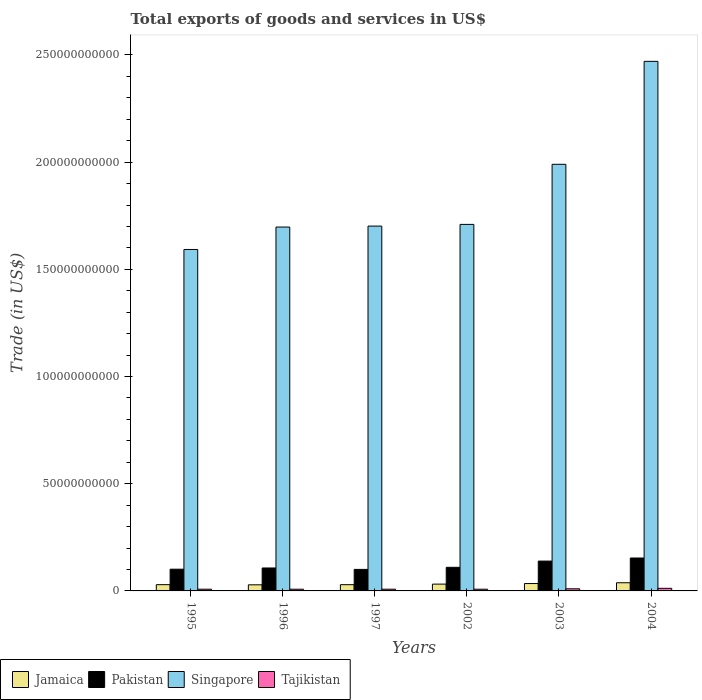How many different coloured bars are there?
Make the answer very short. 4. Are the number of bars on each tick of the X-axis equal?
Give a very brief answer. Yes. What is the total exports of goods and services in Jamaica in 2003?
Make the answer very short. 3.44e+09. Across all years, what is the maximum total exports of goods and services in Pakistan?
Your answer should be very brief. 1.54e+1. Across all years, what is the minimum total exports of goods and services in Tajikistan?
Your response must be concise. 7.99e+08. In which year was the total exports of goods and services in Singapore minimum?
Your response must be concise. 1995. What is the total total exports of goods and services in Tajikistan in the graph?
Ensure brevity in your answer.  5.41e+09. What is the difference between the total exports of goods and services in Jamaica in 1997 and that in 2004?
Ensure brevity in your answer.  -8.97e+08. What is the difference between the total exports of goods and services in Tajikistan in 2003 and the total exports of goods and services in Jamaica in 2004?
Give a very brief answer. -2.83e+09. What is the average total exports of goods and services in Singapore per year?
Your answer should be very brief. 1.86e+11. In the year 1996, what is the difference between the total exports of goods and services in Jamaica and total exports of goods and services in Singapore?
Make the answer very short. -1.67e+11. What is the ratio of the total exports of goods and services in Tajikistan in 2003 to that in 2004?
Give a very brief answer. 0.81. What is the difference between the highest and the second highest total exports of goods and services in Pakistan?
Keep it short and to the point. 1.43e+09. What is the difference between the highest and the lowest total exports of goods and services in Jamaica?
Make the answer very short. 9.63e+08. In how many years, is the total exports of goods and services in Singapore greater than the average total exports of goods and services in Singapore taken over all years?
Provide a succinct answer. 2. Is the sum of the total exports of goods and services in Jamaica in 1995 and 2004 greater than the maximum total exports of goods and services in Tajikistan across all years?
Ensure brevity in your answer.  Yes. Is it the case that in every year, the sum of the total exports of goods and services in Singapore and total exports of goods and services in Jamaica is greater than the sum of total exports of goods and services in Pakistan and total exports of goods and services in Tajikistan?
Ensure brevity in your answer.  No. What does the 1st bar from the left in 2004 represents?
Provide a short and direct response. Jamaica. What does the 4th bar from the right in 2003 represents?
Offer a terse response. Jamaica. Are all the bars in the graph horizontal?
Keep it short and to the point. No. Where does the legend appear in the graph?
Offer a terse response. Bottom left. What is the title of the graph?
Offer a terse response. Total exports of goods and services in US$. What is the label or title of the Y-axis?
Ensure brevity in your answer.  Trade (in US$). What is the Trade (in US$) in Jamaica in 1995?
Offer a very short reply. 2.92e+09. What is the Trade (in US$) in Pakistan in 1995?
Offer a terse response. 1.01e+1. What is the Trade (in US$) of Singapore in 1995?
Your answer should be very brief. 1.59e+11. What is the Trade (in US$) in Tajikistan in 1995?
Offer a very short reply. 8.08e+08. What is the Trade (in US$) of Jamaica in 1996?
Offer a very short reply. 2.85e+09. What is the Trade (in US$) in Pakistan in 1996?
Your answer should be compact. 1.07e+1. What is the Trade (in US$) in Singapore in 1996?
Keep it short and to the point. 1.70e+11. What is the Trade (in US$) of Tajikistan in 1996?
Make the answer very short. 8.00e+08. What is the Trade (in US$) of Jamaica in 1997?
Make the answer very short. 2.91e+09. What is the Trade (in US$) of Pakistan in 1997?
Offer a very short reply. 1.00e+1. What is the Trade (in US$) in Singapore in 1997?
Your response must be concise. 1.70e+11. What is the Trade (in US$) of Tajikistan in 1997?
Provide a short and direct response. 8.04e+08. What is the Trade (in US$) in Jamaica in 2002?
Offer a terse response. 3.18e+09. What is the Trade (in US$) in Pakistan in 2002?
Provide a succinct answer. 1.10e+1. What is the Trade (in US$) of Singapore in 2002?
Give a very brief answer. 1.71e+11. What is the Trade (in US$) of Tajikistan in 2002?
Give a very brief answer. 7.99e+08. What is the Trade (in US$) of Jamaica in 2003?
Provide a succinct answer. 3.44e+09. What is the Trade (in US$) in Pakistan in 2003?
Your response must be concise. 1.39e+1. What is the Trade (in US$) of Singapore in 2003?
Make the answer very short. 1.99e+11. What is the Trade (in US$) in Tajikistan in 2003?
Make the answer very short. 9.85e+08. What is the Trade (in US$) of Jamaica in 2004?
Offer a very short reply. 3.81e+09. What is the Trade (in US$) of Pakistan in 2004?
Your answer should be very brief. 1.54e+1. What is the Trade (in US$) in Singapore in 2004?
Provide a short and direct response. 2.47e+11. What is the Trade (in US$) in Tajikistan in 2004?
Ensure brevity in your answer.  1.21e+09. Across all years, what is the maximum Trade (in US$) of Jamaica?
Ensure brevity in your answer.  3.81e+09. Across all years, what is the maximum Trade (in US$) of Pakistan?
Make the answer very short. 1.54e+1. Across all years, what is the maximum Trade (in US$) of Singapore?
Your response must be concise. 2.47e+11. Across all years, what is the maximum Trade (in US$) of Tajikistan?
Offer a very short reply. 1.21e+09. Across all years, what is the minimum Trade (in US$) in Jamaica?
Give a very brief answer. 2.85e+09. Across all years, what is the minimum Trade (in US$) in Pakistan?
Your answer should be very brief. 1.00e+1. Across all years, what is the minimum Trade (in US$) in Singapore?
Your answer should be very brief. 1.59e+11. Across all years, what is the minimum Trade (in US$) in Tajikistan?
Your answer should be compact. 7.99e+08. What is the total Trade (in US$) of Jamaica in the graph?
Keep it short and to the point. 1.91e+1. What is the total Trade (in US$) of Pakistan in the graph?
Your response must be concise. 7.12e+1. What is the total Trade (in US$) in Singapore in the graph?
Offer a very short reply. 1.12e+12. What is the total Trade (in US$) in Tajikistan in the graph?
Give a very brief answer. 5.41e+09. What is the difference between the Trade (in US$) of Jamaica in 1995 and that in 1996?
Your answer should be very brief. 7.17e+07. What is the difference between the Trade (in US$) of Pakistan in 1995 and that in 1996?
Give a very brief answer. -5.71e+08. What is the difference between the Trade (in US$) of Singapore in 1995 and that in 1996?
Offer a terse response. -1.05e+1. What is the difference between the Trade (in US$) in Tajikistan in 1995 and that in 1996?
Provide a succinct answer. 8.20e+06. What is the difference between the Trade (in US$) of Jamaica in 1995 and that in 1997?
Make the answer very short. 6.07e+06. What is the difference between the Trade (in US$) in Pakistan in 1995 and that in 1997?
Your answer should be very brief. 9.18e+07. What is the difference between the Trade (in US$) of Singapore in 1995 and that in 1997?
Keep it short and to the point. -1.09e+1. What is the difference between the Trade (in US$) of Tajikistan in 1995 and that in 1997?
Make the answer very short. 3.50e+06. What is the difference between the Trade (in US$) of Jamaica in 1995 and that in 2002?
Offer a terse response. -2.56e+08. What is the difference between the Trade (in US$) of Pakistan in 1995 and that in 2002?
Ensure brevity in your answer.  -8.75e+08. What is the difference between the Trade (in US$) of Singapore in 1995 and that in 2002?
Make the answer very short. -1.17e+1. What is the difference between the Trade (in US$) in Tajikistan in 1995 and that in 2002?
Offer a very short reply. 8.34e+06. What is the difference between the Trade (in US$) in Jamaica in 1995 and that in 2003?
Your response must be concise. -5.22e+08. What is the difference between the Trade (in US$) of Pakistan in 1995 and that in 2003?
Your answer should be very brief. -3.79e+09. What is the difference between the Trade (in US$) in Singapore in 1995 and that in 2003?
Give a very brief answer. -3.97e+1. What is the difference between the Trade (in US$) of Tajikistan in 1995 and that in 2003?
Offer a terse response. -1.77e+08. What is the difference between the Trade (in US$) in Jamaica in 1995 and that in 2004?
Keep it short and to the point. -8.91e+08. What is the difference between the Trade (in US$) of Pakistan in 1995 and that in 2004?
Your answer should be very brief. -5.22e+09. What is the difference between the Trade (in US$) of Singapore in 1995 and that in 2004?
Your answer should be very brief. -8.78e+1. What is the difference between the Trade (in US$) of Tajikistan in 1995 and that in 2004?
Ensure brevity in your answer.  -4.03e+08. What is the difference between the Trade (in US$) of Jamaica in 1996 and that in 1997?
Offer a very short reply. -6.57e+07. What is the difference between the Trade (in US$) in Pakistan in 1996 and that in 1997?
Offer a terse response. 6.63e+08. What is the difference between the Trade (in US$) in Singapore in 1996 and that in 1997?
Offer a very short reply. -4.45e+08. What is the difference between the Trade (in US$) of Tajikistan in 1996 and that in 1997?
Ensure brevity in your answer.  -4.70e+06. What is the difference between the Trade (in US$) in Jamaica in 1996 and that in 2002?
Offer a very short reply. -3.28e+08. What is the difference between the Trade (in US$) of Pakistan in 1996 and that in 2002?
Your answer should be very brief. -3.05e+08. What is the difference between the Trade (in US$) of Singapore in 1996 and that in 2002?
Keep it short and to the point. -1.24e+09. What is the difference between the Trade (in US$) in Tajikistan in 1996 and that in 2002?
Your answer should be very brief. 1.45e+05. What is the difference between the Trade (in US$) of Jamaica in 1996 and that in 2003?
Keep it short and to the point. -5.93e+08. What is the difference between the Trade (in US$) of Pakistan in 1996 and that in 2003?
Ensure brevity in your answer.  -3.21e+09. What is the difference between the Trade (in US$) of Singapore in 1996 and that in 2003?
Your answer should be compact. -2.93e+1. What is the difference between the Trade (in US$) in Tajikistan in 1996 and that in 2003?
Provide a succinct answer. -1.85e+08. What is the difference between the Trade (in US$) in Jamaica in 1996 and that in 2004?
Give a very brief answer. -9.63e+08. What is the difference between the Trade (in US$) of Pakistan in 1996 and that in 2004?
Offer a very short reply. -4.65e+09. What is the difference between the Trade (in US$) of Singapore in 1996 and that in 2004?
Offer a terse response. -7.73e+1. What is the difference between the Trade (in US$) of Tajikistan in 1996 and that in 2004?
Make the answer very short. -4.11e+08. What is the difference between the Trade (in US$) of Jamaica in 1997 and that in 2002?
Your answer should be compact. -2.62e+08. What is the difference between the Trade (in US$) in Pakistan in 1997 and that in 2002?
Your answer should be compact. -9.67e+08. What is the difference between the Trade (in US$) of Singapore in 1997 and that in 2002?
Offer a very short reply. -7.93e+08. What is the difference between the Trade (in US$) of Tajikistan in 1997 and that in 2002?
Offer a very short reply. 4.84e+06. What is the difference between the Trade (in US$) of Jamaica in 1997 and that in 2003?
Offer a terse response. -5.28e+08. What is the difference between the Trade (in US$) of Pakistan in 1997 and that in 2003?
Provide a succinct answer. -3.88e+09. What is the difference between the Trade (in US$) of Singapore in 1997 and that in 2003?
Your answer should be compact. -2.88e+1. What is the difference between the Trade (in US$) of Tajikistan in 1997 and that in 2003?
Your answer should be very brief. -1.81e+08. What is the difference between the Trade (in US$) in Jamaica in 1997 and that in 2004?
Your answer should be very brief. -8.97e+08. What is the difference between the Trade (in US$) of Pakistan in 1997 and that in 2004?
Ensure brevity in your answer.  -5.31e+09. What is the difference between the Trade (in US$) of Singapore in 1997 and that in 2004?
Offer a very short reply. -7.68e+1. What is the difference between the Trade (in US$) in Tajikistan in 1997 and that in 2004?
Provide a succinct answer. -4.06e+08. What is the difference between the Trade (in US$) in Jamaica in 2002 and that in 2003?
Keep it short and to the point. -2.65e+08. What is the difference between the Trade (in US$) of Pakistan in 2002 and that in 2003?
Offer a very short reply. -2.91e+09. What is the difference between the Trade (in US$) in Singapore in 2002 and that in 2003?
Ensure brevity in your answer.  -2.80e+1. What is the difference between the Trade (in US$) of Tajikistan in 2002 and that in 2003?
Your answer should be compact. -1.86e+08. What is the difference between the Trade (in US$) in Jamaica in 2002 and that in 2004?
Your response must be concise. -6.35e+08. What is the difference between the Trade (in US$) in Pakistan in 2002 and that in 2004?
Your response must be concise. -4.34e+09. What is the difference between the Trade (in US$) in Singapore in 2002 and that in 2004?
Make the answer very short. -7.61e+1. What is the difference between the Trade (in US$) in Tajikistan in 2002 and that in 2004?
Your response must be concise. -4.11e+08. What is the difference between the Trade (in US$) of Jamaica in 2003 and that in 2004?
Make the answer very short. -3.70e+08. What is the difference between the Trade (in US$) of Pakistan in 2003 and that in 2004?
Provide a succinct answer. -1.43e+09. What is the difference between the Trade (in US$) in Singapore in 2003 and that in 2004?
Keep it short and to the point. -4.80e+1. What is the difference between the Trade (in US$) of Tajikistan in 2003 and that in 2004?
Ensure brevity in your answer.  -2.26e+08. What is the difference between the Trade (in US$) in Jamaica in 1995 and the Trade (in US$) in Pakistan in 1996?
Keep it short and to the point. -7.78e+09. What is the difference between the Trade (in US$) in Jamaica in 1995 and the Trade (in US$) in Singapore in 1996?
Give a very brief answer. -1.67e+11. What is the difference between the Trade (in US$) of Jamaica in 1995 and the Trade (in US$) of Tajikistan in 1996?
Your answer should be very brief. 2.12e+09. What is the difference between the Trade (in US$) in Pakistan in 1995 and the Trade (in US$) in Singapore in 1996?
Make the answer very short. -1.60e+11. What is the difference between the Trade (in US$) in Pakistan in 1995 and the Trade (in US$) in Tajikistan in 1996?
Offer a terse response. 9.33e+09. What is the difference between the Trade (in US$) in Singapore in 1995 and the Trade (in US$) in Tajikistan in 1996?
Your answer should be compact. 1.58e+11. What is the difference between the Trade (in US$) of Jamaica in 1995 and the Trade (in US$) of Pakistan in 1997?
Your answer should be compact. -7.12e+09. What is the difference between the Trade (in US$) of Jamaica in 1995 and the Trade (in US$) of Singapore in 1997?
Ensure brevity in your answer.  -1.67e+11. What is the difference between the Trade (in US$) of Jamaica in 1995 and the Trade (in US$) of Tajikistan in 1997?
Provide a succinct answer. 2.12e+09. What is the difference between the Trade (in US$) in Pakistan in 1995 and the Trade (in US$) in Singapore in 1997?
Your answer should be very brief. -1.60e+11. What is the difference between the Trade (in US$) of Pakistan in 1995 and the Trade (in US$) of Tajikistan in 1997?
Your answer should be very brief. 9.33e+09. What is the difference between the Trade (in US$) of Singapore in 1995 and the Trade (in US$) of Tajikistan in 1997?
Offer a terse response. 1.58e+11. What is the difference between the Trade (in US$) in Jamaica in 1995 and the Trade (in US$) in Pakistan in 2002?
Give a very brief answer. -8.09e+09. What is the difference between the Trade (in US$) in Jamaica in 1995 and the Trade (in US$) in Singapore in 2002?
Ensure brevity in your answer.  -1.68e+11. What is the difference between the Trade (in US$) of Jamaica in 1995 and the Trade (in US$) of Tajikistan in 2002?
Ensure brevity in your answer.  2.12e+09. What is the difference between the Trade (in US$) in Pakistan in 1995 and the Trade (in US$) in Singapore in 2002?
Offer a terse response. -1.61e+11. What is the difference between the Trade (in US$) of Pakistan in 1995 and the Trade (in US$) of Tajikistan in 2002?
Give a very brief answer. 9.33e+09. What is the difference between the Trade (in US$) in Singapore in 1995 and the Trade (in US$) in Tajikistan in 2002?
Ensure brevity in your answer.  1.58e+11. What is the difference between the Trade (in US$) in Jamaica in 1995 and the Trade (in US$) in Pakistan in 2003?
Give a very brief answer. -1.10e+1. What is the difference between the Trade (in US$) of Jamaica in 1995 and the Trade (in US$) of Singapore in 2003?
Provide a succinct answer. -1.96e+11. What is the difference between the Trade (in US$) of Jamaica in 1995 and the Trade (in US$) of Tajikistan in 2003?
Provide a short and direct response. 1.93e+09. What is the difference between the Trade (in US$) in Pakistan in 1995 and the Trade (in US$) in Singapore in 2003?
Ensure brevity in your answer.  -1.89e+11. What is the difference between the Trade (in US$) of Pakistan in 1995 and the Trade (in US$) of Tajikistan in 2003?
Keep it short and to the point. 9.15e+09. What is the difference between the Trade (in US$) of Singapore in 1995 and the Trade (in US$) of Tajikistan in 2003?
Give a very brief answer. 1.58e+11. What is the difference between the Trade (in US$) of Jamaica in 1995 and the Trade (in US$) of Pakistan in 2004?
Your answer should be compact. -1.24e+1. What is the difference between the Trade (in US$) in Jamaica in 1995 and the Trade (in US$) in Singapore in 2004?
Ensure brevity in your answer.  -2.44e+11. What is the difference between the Trade (in US$) of Jamaica in 1995 and the Trade (in US$) of Tajikistan in 2004?
Keep it short and to the point. 1.71e+09. What is the difference between the Trade (in US$) in Pakistan in 1995 and the Trade (in US$) in Singapore in 2004?
Keep it short and to the point. -2.37e+11. What is the difference between the Trade (in US$) in Pakistan in 1995 and the Trade (in US$) in Tajikistan in 2004?
Make the answer very short. 8.92e+09. What is the difference between the Trade (in US$) of Singapore in 1995 and the Trade (in US$) of Tajikistan in 2004?
Keep it short and to the point. 1.58e+11. What is the difference between the Trade (in US$) of Jamaica in 1996 and the Trade (in US$) of Pakistan in 1997?
Ensure brevity in your answer.  -7.19e+09. What is the difference between the Trade (in US$) of Jamaica in 1996 and the Trade (in US$) of Singapore in 1997?
Give a very brief answer. -1.67e+11. What is the difference between the Trade (in US$) of Jamaica in 1996 and the Trade (in US$) of Tajikistan in 1997?
Offer a terse response. 2.04e+09. What is the difference between the Trade (in US$) in Pakistan in 1996 and the Trade (in US$) in Singapore in 1997?
Ensure brevity in your answer.  -1.59e+11. What is the difference between the Trade (in US$) of Pakistan in 1996 and the Trade (in US$) of Tajikistan in 1997?
Offer a terse response. 9.90e+09. What is the difference between the Trade (in US$) in Singapore in 1996 and the Trade (in US$) in Tajikistan in 1997?
Your response must be concise. 1.69e+11. What is the difference between the Trade (in US$) in Jamaica in 1996 and the Trade (in US$) in Pakistan in 2002?
Offer a very short reply. -8.16e+09. What is the difference between the Trade (in US$) in Jamaica in 1996 and the Trade (in US$) in Singapore in 2002?
Your response must be concise. -1.68e+11. What is the difference between the Trade (in US$) in Jamaica in 1996 and the Trade (in US$) in Tajikistan in 2002?
Give a very brief answer. 2.05e+09. What is the difference between the Trade (in US$) in Pakistan in 1996 and the Trade (in US$) in Singapore in 2002?
Your answer should be compact. -1.60e+11. What is the difference between the Trade (in US$) in Pakistan in 1996 and the Trade (in US$) in Tajikistan in 2002?
Your response must be concise. 9.90e+09. What is the difference between the Trade (in US$) in Singapore in 1996 and the Trade (in US$) in Tajikistan in 2002?
Keep it short and to the point. 1.69e+11. What is the difference between the Trade (in US$) in Jamaica in 1996 and the Trade (in US$) in Pakistan in 2003?
Your response must be concise. -1.11e+1. What is the difference between the Trade (in US$) of Jamaica in 1996 and the Trade (in US$) of Singapore in 2003?
Your response must be concise. -1.96e+11. What is the difference between the Trade (in US$) in Jamaica in 1996 and the Trade (in US$) in Tajikistan in 2003?
Provide a short and direct response. 1.86e+09. What is the difference between the Trade (in US$) in Pakistan in 1996 and the Trade (in US$) in Singapore in 2003?
Ensure brevity in your answer.  -1.88e+11. What is the difference between the Trade (in US$) of Pakistan in 1996 and the Trade (in US$) of Tajikistan in 2003?
Give a very brief answer. 9.72e+09. What is the difference between the Trade (in US$) in Singapore in 1996 and the Trade (in US$) in Tajikistan in 2003?
Provide a short and direct response. 1.69e+11. What is the difference between the Trade (in US$) of Jamaica in 1996 and the Trade (in US$) of Pakistan in 2004?
Make the answer very short. -1.25e+1. What is the difference between the Trade (in US$) in Jamaica in 1996 and the Trade (in US$) in Singapore in 2004?
Your answer should be very brief. -2.44e+11. What is the difference between the Trade (in US$) in Jamaica in 1996 and the Trade (in US$) in Tajikistan in 2004?
Offer a very short reply. 1.64e+09. What is the difference between the Trade (in US$) of Pakistan in 1996 and the Trade (in US$) of Singapore in 2004?
Keep it short and to the point. -2.36e+11. What is the difference between the Trade (in US$) in Pakistan in 1996 and the Trade (in US$) in Tajikistan in 2004?
Offer a very short reply. 9.49e+09. What is the difference between the Trade (in US$) of Singapore in 1996 and the Trade (in US$) of Tajikistan in 2004?
Make the answer very short. 1.69e+11. What is the difference between the Trade (in US$) in Jamaica in 1997 and the Trade (in US$) in Pakistan in 2002?
Provide a succinct answer. -8.09e+09. What is the difference between the Trade (in US$) in Jamaica in 1997 and the Trade (in US$) in Singapore in 2002?
Keep it short and to the point. -1.68e+11. What is the difference between the Trade (in US$) of Jamaica in 1997 and the Trade (in US$) of Tajikistan in 2002?
Make the answer very short. 2.11e+09. What is the difference between the Trade (in US$) of Pakistan in 1997 and the Trade (in US$) of Singapore in 2002?
Ensure brevity in your answer.  -1.61e+11. What is the difference between the Trade (in US$) in Pakistan in 1997 and the Trade (in US$) in Tajikistan in 2002?
Provide a succinct answer. 9.24e+09. What is the difference between the Trade (in US$) in Singapore in 1997 and the Trade (in US$) in Tajikistan in 2002?
Ensure brevity in your answer.  1.69e+11. What is the difference between the Trade (in US$) of Jamaica in 1997 and the Trade (in US$) of Pakistan in 2003?
Your response must be concise. -1.10e+1. What is the difference between the Trade (in US$) of Jamaica in 1997 and the Trade (in US$) of Singapore in 2003?
Your answer should be very brief. -1.96e+11. What is the difference between the Trade (in US$) of Jamaica in 1997 and the Trade (in US$) of Tajikistan in 2003?
Ensure brevity in your answer.  1.93e+09. What is the difference between the Trade (in US$) in Pakistan in 1997 and the Trade (in US$) in Singapore in 2003?
Ensure brevity in your answer.  -1.89e+11. What is the difference between the Trade (in US$) in Pakistan in 1997 and the Trade (in US$) in Tajikistan in 2003?
Keep it short and to the point. 9.06e+09. What is the difference between the Trade (in US$) in Singapore in 1997 and the Trade (in US$) in Tajikistan in 2003?
Your answer should be compact. 1.69e+11. What is the difference between the Trade (in US$) in Jamaica in 1997 and the Trade (in US$) in Pakistan in 2004?
Your answer should be very brief. -1.24e+1. What is the difference between the Trade (in US$) in Jamaica in 1997 and the Trade (in US$) in Singapore in 2004?
Provide a short and direct response. -2.44e+11. What is the difference between the Trade (in US$) in Jamaica in 1997 and the Trade (in US$) in Tajikistan in 2004?
Keep it short and to the point. 1.70e+09. What is the difference between the Trade (in US$) of Pakistan in 1997 and the Trade (in US$) of Singapore in 2004?
Provide a succinct answer. -2.37e+11. What is the difference between the Trade (in US$) of Pakistan in 1997 and the Trade (in US$) of Tajikistan in 2004?
Keep it short and to the point. 8.83e+09. What is the difference between the Trade (in US$) in Singapore in 1997 and the Trade (in US$) in Tajikistan in 2004?
Your answer should be very brief. 1.69e+11. What is the difference between the Trade (in US$) in Jamaica in 2002 and the Trade (in US$) in Pakistan in 2003?
Make the answer very short. -1.07e+1. What is the difference between the Trade (in US$) of Jamaica in 2002 and the Trade (in US$) of Singapore in 2003?
Offer a terse response. -1.96e+11. What is the difference between the Trade (in US$) of Jamaica in 2002 and the Trade (in US$) of Tajikistan in 2003?
Your answer should be very brief. 2.19e+09. What is the difference between the Trade (in US$) in Pakistan in 2002 and the Trade (in US$) in Singapore in 2003?
Offer a terse response. -1.88e+11. What is the difference between the Trade (in US$) of Pakistan in 2002 and the Trade (in US$) of Tajikistan in 2003?
Your answer should be very brief. 1.00e+1. What is the difference between the Trade (in US$) in Singapore in 2002 and the Trade (in US$) in Tajikistan in 2003?
Give a very brief answer. 1.70e+11. What is the difference between the Trade (in US$) of Jamaica in 2002 and the Trade (in US$) of Pakistan in 2004?
Offer a very short reply. -1.22e+1. What is the difference between the Trade (in US$) of Jamaica in 2002 and the Trade (in US$) of Singapore in 2004?
Provide a succinct answer. -2.44e+11. What is the difference between the Trade (in US$) of Jamaica in 2002 and the Trade (in US$) of Tajikistan in 2004?
Ensure brevity in your answer.  1.97e+09. What is the difference between the Trade (in US$) in Pakistan in 2002 and the Trade (in US$) in Singapore in 2004?
Your answer should be compact. -2.36e+11. What is the difference between the Trade (in US$) in Pakistan in 2002 and the Trade (in US$) in Tajikistan in 2004?
Make the answer very short. 9.80e+09. What is the difference between the Trade (in US$) in Singapore in 2002 and the Trade (in US$) in Tajikistan in 2004?
Your answer should be compact. 1.70e+11. What is the difference between the Trade (in US$) in Jamaica in 2003 and the Trade (in US$) in Pakistan in 2004?
Provide a succinct answer. -1.19e+1. What is the difference between the Trade (in US$) of Jamaica in 2003 and the Trade (in US$) of Singapore in 2004?
Provide a succinct answer. -2.44e+11. What is the difference between the Trade (in US$) in Jamaica in 2003 and the Trade (in US$) in Tajikistan in 2004?
Provide a succinct answer. 2.23e+09. What is the difference between the Trade (in US$) in Pakistan in 2003 and the Trade (in US$) in Singapore in 2004?
Keep it short and to the point. -2.33e+11. What is the difference between the Trade (in US$) of Pakistan in 2003 and the Trade (in US$) of Tajikistan in 2004?
Your answer should be compact. 1.27e+1. What is the difference between the Trade (in US$) in Singapore in 2003 and the Trade (in US$) in Tajikistan in 2004?
Provide a succinct answer. 1.98e+11. What is the average Trade (in US$) of Jamaica per year?
Offer a very short reply. 3.19e+09. What is the average Trade (in US$) in Pakistan per year?
Ensure brevity in your answer.  1.19e+1. What is the average Trade (in US$) in Singapore per year?
Ensure brevity in your answer.  1.86e+11. What is the average Trade (in US$) in Tajikistan per year?
Your response must be concise. 9.01e+08. In the year 1995, what is the difference between the Trade (in US$) in Jamaica and Trade (in US$) in Pakistan?
Give a very brief answer. -7.21e+09. In the year 1995, what is the difference between the Trade (in US$) in Jamaica and Trade (in US$) in Singapore?
Ensure brevity in your answer.  -1.56e+11. In the year 1995, what is the difference between the Trade (in US$) in Jamaica and Trade (in US$) in Tajikistan?
Keep it short and to the point. 2.11e+09. In the year 1995, what is the difference between the Trade (in US$) of Pakistan and Trade (in US$) of Singapore?
Your answer should be compact. -1.49e+11. In the year 1995, what is the difference between the Trade (in US$) in Pakistan and Trade (in US$) in Tajikistan?
Give a very brief answer. 9.32e+09. In the year 1995, what is the difference between the Trade (in US$) of Singapore and Trade (in US$) of Tajikistan?
Give a very brief answer. 1.58e+11. In the year 1996, what is the difference between the Trade (in US$) of Jamaica and Trade (in US$) of Pakistan?
Make the answer very short. -7.86e+09. In the year 1996, what is the difference between the Trade (in US$) of Jamaica and Trade (in US$) of Singapore?
Your response must be concise. -1.67e+11. In the year 1996, what is the difference between the Trade (in US$) in Jamaica and Trade (in US$) in Tajikistan?
Provide a succinct answer. 2.05e+09. In the year 1996, what is the difference between the Trade (in US$) of Pakistan and Trade (in US$) of Singapore?
Offer a very short reply. -1.59e+11. In the year 1996, what is the difference between the Trade (in US$) in Pakistan and Trade (in US$) in Tajikistan?
Keep it short and to the point. 9.90e+09. In the year 1996, what is the difference between the Trade (in US$) in Singapore and Trade (in US$) in Tajikistan?
Provide a short and direct response. 1.69e+11. In the year 1997, what is the difference between the Trade (in US$) in Jamaica and Trade (in US$) in Pakistan?
Provide a succinct answer. -7.13e+09. In the year 1997, what is the difference between the Trade (in US$) in Jamaica and Trade (in US$) in Singapore?
Give a very brief answer. -1.67e+11. In the year 1997, what is the difference between the Trade (in US$) in Jamaica and Trade (in US$) in Tajikistan?
Keep it short and to the point. 2.11e+09. In the year 1997, what is the difference between the Trade (in US$) of Pakistan and Trade (in US$) of Singapore?
Offer a very short reply. -1.60e+11. In the year 1997, what is the difference between the Trade (in US$) of Pakistan and Trade (in US$) of Tajikistan?
Keep it short and to the point. 9.24e+09. In the year 1997, what is the difference between the Trade (in US$) in Singapore and Trade (in US$) in Tajikistan?
Provide a short and direct response. 1.69e+11. In the year 2002, what is the difference between the Trade (in US$) in Jamaica and Trade (in US$) in Pakistan?
Your answer should be very brief. -7.83e+09. In the year 2002, what is the difference between the Trade (in US$) of Jamaica and Trade (in US$) of Singapore?
Make the answer very short. -1.68e+11. In the year 2002, what is the difference between the Trade (in US$) of Jamaica and Trade (in US$) of Tajikistan?
Your answer should be very brief. 2.38e+09. In the year 2002, what is the difference between the Trade (in US$) of Pakistan and Trade (in US$) of Singapore?
Give a very brief answer. -1.60e+11. In the year 2002, what is the difference between the Trade (in US$) in Pakistan and Trade (in US$) in Tajikistan?
Offer a very short reply. 1.02e+1. In the year 2002, what is the difference between the Trade (in US$) in Singapore and Trade (in US$) in Tajikistan?
Provide a succinct answer. 1.70e+11. In the year 2003, what is the difference between the Trade (in US$) of Jamaica and Trade (in US$) of Pakistan?
Offer a very short reply. -1.05e+1. In the year 2003, what is the difference between the Trade (in US$) of Jamaica and Trade (in US$) of Singapore?
Your response must be concise. -1.96e+11. In the year 2003, what is the difference between the Trade (in US$) of Jamaica and Trade (in US$) of Tajikistan?
Keep it short and to the point. 2.46e+09. In the year 2003, what is the difference between the Trade (in US$) in Pakistan and Trade (in US$) in Singapore?
Ensure brevity in your answer.  -1.85e+11. In the year 2003, what is the difference between the Trade (in US$) of Pakistan and Trade (in US$) of Tajikistan?
Your answer should be very brief. 1.29e+1. In the year 2003, what is the difference between the Trade (in US$) of Singapore and Trade (in US$) of Tajikistan?
Offer a terse response. 1.98e+11. In the year 2004, what is the difference between the Trade (in US$) in Jamaica and Trade (in US$) in Pakistan?
Offer a very short reply. -1.15e+1. In the year 2004, what is the difference between the Trade (in US$) of Jamaica and Trade (in US$) of Singapore?
Provide a succinct answer. -2.43e+11. In the year 2004, what is the difference between the Trade (in US$) of Jamaica and Trade (in US$) of Tajikistan?
Offer a very short reply. 2.60e+09. In the year 2004, what is the difference between the Trade (in US$) of Pakistan and Trade (in US$) of Singapore?
Give a very brief answer. -2.32e+11. In the year 2004, what is the difference between the Trade (in US$) in Pakistan and Trade (in US$) in Tajikistan?
Provide a succinct answer. 1.41e+1. In the year 2004, what is the difference between the Trade (in US$) in Singapore and Trade (in US$) in Tajikistan?
Keep it short and to the point. 2.46e+11. What is the ratio of the Trade (in US$) in Jamaica in 1995 to that in 1996?
Provide a short and direct response. 1.03. What is the ratio of the Trade (in US$) of Pakistan in 1995 to that in 1996?
Keep it short and to the point. 0.95. What is the ratio of the Trade (in US$) of Singapore in 1995 to that in 1996?
Your answer should be very brief. 0.94. What is the ratio of the Trade (in US$) of Tajikistan in 1995 to that in 1996?
Ensure brevity in your answer.  1.01. What is the ratio of the Trade (in US$) of Jamaica in 1995 to that in 1997?
Your answer should be compact. 1. What is the ratio of the Trade (in US$) in Pakistan in 1995 to that in 1997?
Offer a terse response. 1.01. What is the ratio of the Trade (in US$) of Singapore in 1995 to that in 1997?
Ensure brevity in your answer.  0.94. What is the ratio of the Trade (in US$) of Jamaica in 1995 to that in 2002?
Give a very brief answer. 0.92. What is the ratio of the Trade (in US$) of Pakistan in 1995 to that in 2002?
Offer a very short reply. 0.92. What is the ratio of the Trade (in US$) of Singapore in 1995 to that in 2002?
Provide a short and direct response. 0.93. What is the ratio of the Trade (in US$) in Tajikistan in 1995 to that in 2002?
Your answer should be very brief. 1.01. What is the ratio of the Trade (in US$) of Jamaica in 1995 to that in 2003?
Provide a short and direct response. 0.85. What is the ratio of the Trade (in US$) in Pakistan in 1995 to that in 2003?
Offer a terse response. 0.73. What is the ratio of the Trade (in US$) in Singapore in 1995 to that in 2003?
Provide a short and direct response. 0.8. What is the ratio of the Trade (in US$) in Tajikistan in 1995 to that in 2003?
Keep it short and to the point. 0.82. What is the ratio of the Trade (in US$) in Jamaica in 1995 to that in 2004?
Ensure brevity in your answer.  0.77. What is the ratio of the Trade (in US$) of Pakistan in 1995 to that in 2004?
Ensure brevity in your answer.  0.66. What is the ratio of the Trade (in US$) in Singapore in 1995 to that in 2004?
Offer a very short reply. 0.64. What is the ratio of the Trade (in US$) in Tajikistan in 1995 to that in 2004?
Make the answer very short. 0.67. What is the ratio of the Trade (in US$) of Jamaica in 1996 to that in 1997?
Offer a terse response. 0.98. What is the ratio of the Trade (in US$) of Pakistan in 1996 to that in 1997?
Your answer should be compact. 1.07. What is the ratio of the Trade (in US$) in Jamaica in 1996 to that in 2002?
Offer a very short reply. 0.9. What is the ratio of the Trade (in US$) in Pakistan in 1996 to that in 2002?
Your answer should be compact. 0.97. What is the ratio of the Trade (in US$) of Jamaica in 1996 to that in 2003?
Your response must be concise. 0.83. What is the ratio of the Trade (in US$) in Pakistan in 1996 to that in 2003?
Your response must be concise. 0.77. What is the ratio of the Trade (in US$) of Singapore in 1996 to that in 2003?
Your answer should be very brief. 0.85. What is the ratio of the Trade (in US$) in Tajikistan in 1996 to that in 2003?
Give a very brief answer. 0.81. What is the ratio of the Trade (in US$) in Jamaica in 1996 to that in 2004?
Your answer should be very brief. 0.75. What is the ratio of the Trade (in US$) in Pakistan in 1996 to that in 2004?
Your answer should be compact. 0.7. What is the ratio of the Trade (in US$) of Singapore in 1996 to that in 2004?
Keep it short and to the point. 0.69. What is the ratio of the Trade (in US$) in Tajikistan in 1996 to that in 2004?
Your answer should be very brief. 0.66. What is the ratio of the Trade (in US$) of Jamaica in 1997 to that in 2002?
Your response must be concise. 0.92. What is the ratio of the Trade (in US$) of Pakistan in 1997 to that in 2002?
Provide a short and direct response. 0.91. What is the ratio of the Trade (in US$) of Jamaica in 1997 to that in 2003?
Provide a short and direct response. 0.85. What is the ratio of the Trade (in US$) in Pakistan in 1997 to that in 2003?
Offer a terse response. 0.72. What is the ratio of the Trade (in US$) in Singapore in 1997 to that in 2003?
Your answer should be compact. 0.86. What is the ratio of the Trade (in US$) in Tajikistan in 1997 to that in 2003?
Provide a succinct answer. 0.82. What is the ratio of the Trade (in US$) in Jamaica in 1997 to that in 2004?
Make the answer very short. 0.76. What is the ratio of the Trade (in US$) of Pakistan in 1997 to that in 2004?
Offer a very short reply. 0.65. What is the ratio of the Trade (in US$) of Singapore in 1997 to that in 2004?
Ensure brevity in your answer.  0.69. What is the ratio of the Trade (in US$) in Tajikistan in 1997 to that in 2004?
Offer a very short reply. 0.66. What is the ratio of the Trade (in US$) of Jamaica in 2002 to that in 2003?
Offer a terse response. 0.92. What is the ratio of the Trade (in US$) in Pakistan in 2002 to that in 2003?
Provide a succinct answer. 0.79. What is the ratio of the Trade (in US$) of Singapore in 2002 to that in 2003?
Your answer should be very brief. 0.86. What is the ratio of the Trade (in US$) in Tajikistan in 2002 to that in 2003?
Ensure brevity in your answer.  0.81. What is the ratio of the Trade (in US$) of Jamaica in 2002 to that in 2004?
Ensure brevity in your answer.  0.83. What is the ratio of the Trade (in US$) in Pakistan in 2002 to that in 2004?
Your response must be concise. 0.72. What is the ratio of the Trade (in US$) in Singapore in 2002 to that in 2004?
Offer a terse response. 0.69. What is the ratio of the Trade (in US$) of Tajikistan in 2002 to that in 2004?
Provide a short and direct response. 0.66. What is the ratio of the Trade (in US$) in Jamaica in 2003 to that in 2004?
Give a very brief answer. 0.9. What is the ratio of the Trade (in US$) in Pakistan in 2003 to that in 2004?
Provide a succinct answer. 0.91. What is the ratio of the Trade (in US$) of Singapore in 2003 to that in 2004?
Offer a very short reply. 0.81. What is the ratio of the Trade (in US$) in Tajikistan in 2003 to that in 2004?
Make the answer very short. 0.81. What is the difference between the highest and the second highest Trade (in US$) in Jamaica?
Your answer should be compact. 3.70e+08. What is the difference between the highest and the second highest Trade (in US$) of Pakistan?
Provide a succinct answer. 1.43e+09. What is the difference between the highest and the second highest Trade (in US$) of Singapore?
Offer a very short reply. 4.80e+1. What is the difference between the highest and the second highest Trade (in US$) in Tajikistan?
Your answer should be compact. 2.26e+08. What is the difference between the highest and the lowest Trade (in US$) of Jamaica?
Your response must be concise. 9.63e+08. What is the difference between the highest and the lowest Trade (in US$) in Pakistan?
Offer a terse response. 5.31e+09. What is the difference between the highest and the lowest Trade (in US$) of Singapore?
Your answer should be compact. 8.78e+1. What is the difference between the highest and the lowest Trade (in US$) of Tajikistan?
Ensure brevity in your answer.  4.11e+08. 